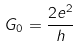Convert formula to latex. <formula><loc_0><loc_0><loc_500><loc_500>G _ { 0 } = \frac { 2 e ^ { 2 } } { h }</formula> 